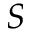<formula> <loc_0><loc_0><loc_500><loc_500>S</formula> 